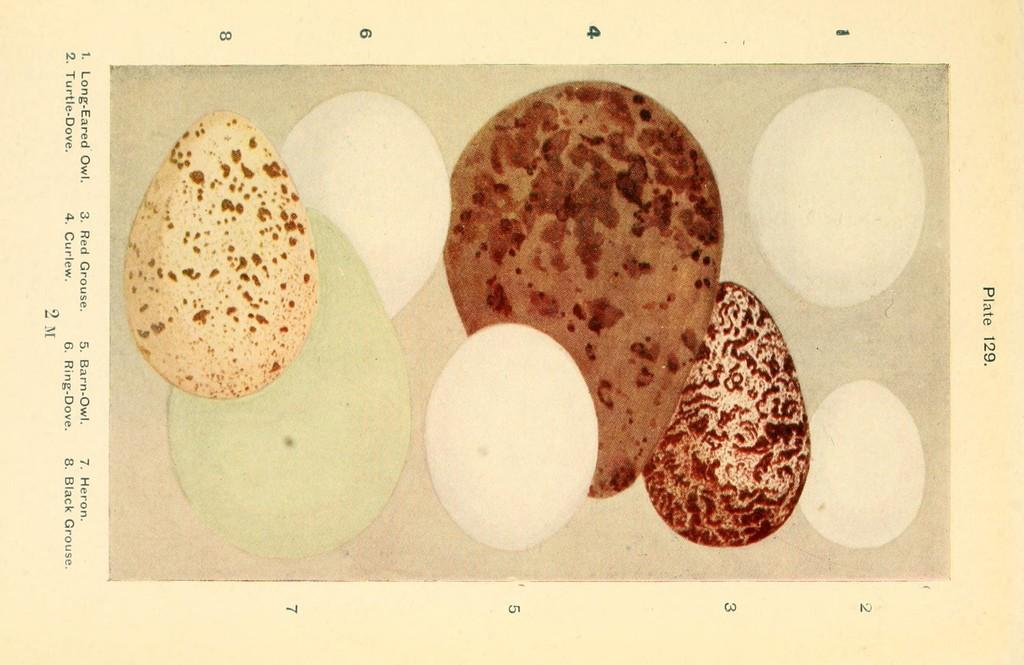What is the main subject of the image? The main subject of the image is a types of eggs poster. Can you describe the poster in more detail? Unfortunately, the provided facts do not offer any additional details about the poster. What type of produce is being celebrated on the birthday in the image? There is no information about a birthday or produce in the image, as it only features a types of eggs poster. 